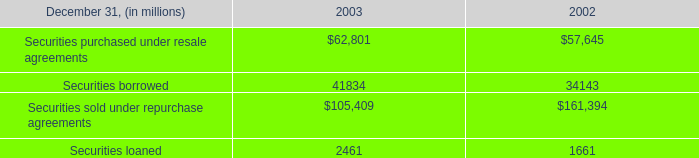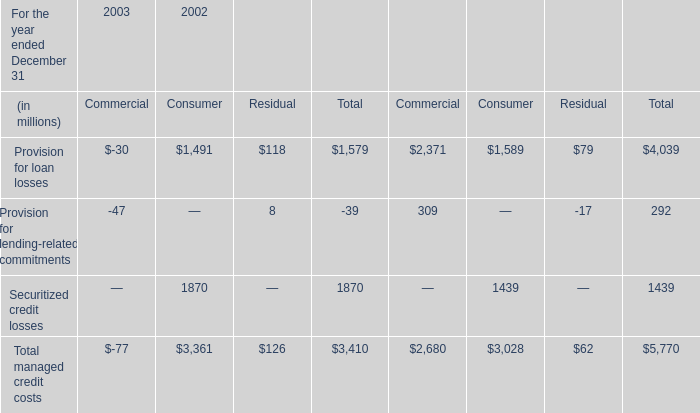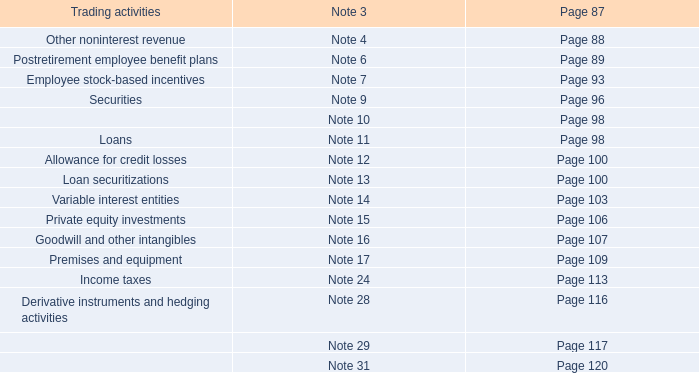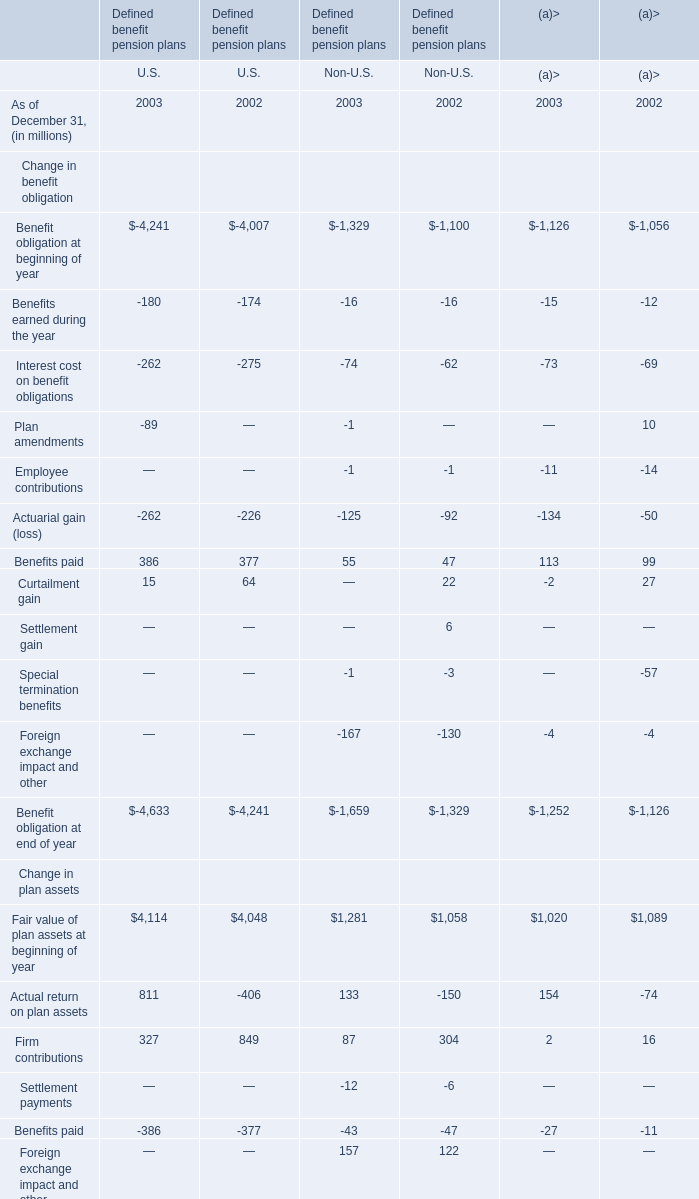what was the ratio of the accounted for as purchases under sfas 14 in 2003 to 2002 
Computations: (15 / 8)
Answer: 1.875. 